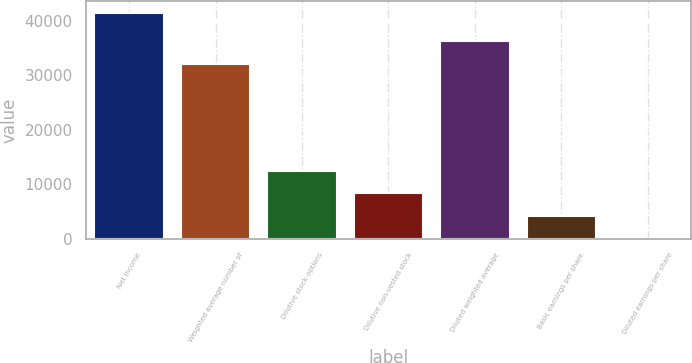<chart> <loc_0><loc_0><loc_500><loc_500><bar_chart><fcel>Net income<fcel>Weighted average number of<fcel>Dilutive stock options<fcel>Dilutive non-vested stock<fcel>Diluted weighted average<fcel>Basic earnings per share<fcel>Diluted earnings per share<nl><fcel>41423<fcel>32051<fcel>12427.8<fcel>8285.62<fcel>36193.2<fcel>4143.45<fcel>1.28<nl></chart> 